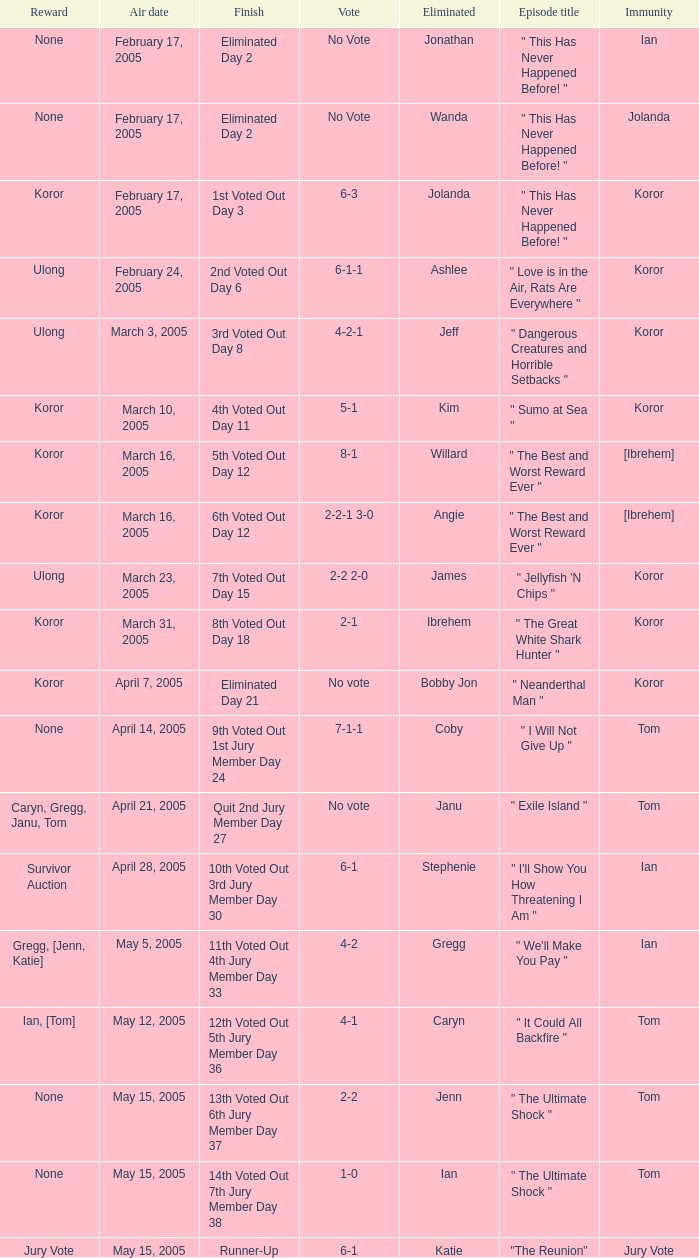Who received the reward on the episode where the finish was "3rd voted out day 8"? Ulong. 